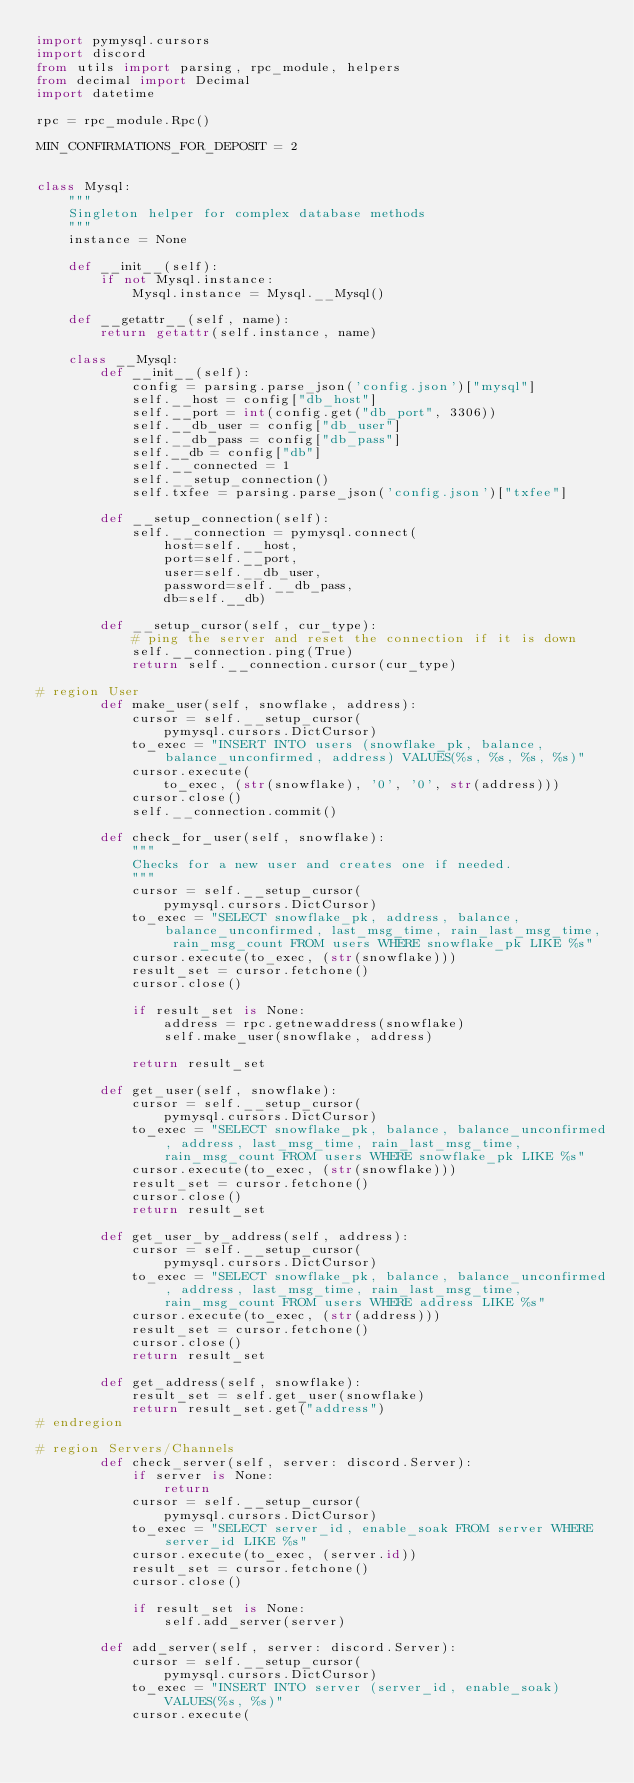Convert code to text. <code><loc_0><loc_0><loc_500><loc_500><_Python_>import pymysql.cursors
import discord
from utils import parsing, rpc_module, helpers
from decimal import Decimal
import datetime

rpc = rpc_module.Rpc()

MIN_CONFIRMATIONS_FOR_DEPOSIT = 2


class Mysql:
    """
    Singleton helper for complex database methods
    """
    instance = None

    def __init__(self):
        if not Mysql.instance:
            Mysql.instance = Mysql.__Mysql()

    def __getattr__(self, name):
        return getattr(self.instance, name)

    class __Mysql:
        def __init__(self):
            config = parsing.parse_json('config.json')["mysql"]
            self.__host = config["db_host"]
            self.__port = int(config.get("db_port", 3306))
            self.__db_user = config["db_user"]
            self.__db_pass = config["db_pass"]
            self.__db = config["db"]
            self.__connected = 1
            self.__setup_connection()
            self.txfee = parsing.parse_json('config.json')["txfee"]

        def __setup_connection(self):
            self.__connection = pymysql.connect(
                host=self.__host,
                port=self.__port,
                user=self.__db_user,
                password=self.__db_pass,
                db=self.__db)

        def __setup_cursor(self, cur_type):
            # ping the server and reset the connection if it is down
            self.__connection.ping(True)
            return self.__connection.cursor(cur_type)

# region User
        def make_user(self, snowflake, address):
            cursor = self.__setup_cursor(
                pymysql.cursors.DictCursor)
            to_exec = "INSERT INTO users (snowflake_pk, balance, balance_unconfirmed, address) VALUES(%s, %s, %s, %s)"
            cursor.execute(
                to_exec, (str(snowflake), '0', '0', str(address)))
            cursor.close()
            self.__connection.commit()

        def check_for_user(self, snowflake):
            """
            Checks for a new user and creates one if needed.
            """
            cursor = self.__setup_cursor(
                pymysql.cursors.DictCursor)
            to_exec = "SELECT snowflake_pk, address, balance, balance_unconfirmed, last_msg_time, rain_last_msg_time, rain_msg_count FROM users WHERE snowflake_pk LIKE %s"
            cursor.execute(to_exec, (str(snowflake)))
            result_set = cursor.fetchone()
            cursor.close()

            if result_set is None:
                address = rpc.getnewaddress(snowflake)
                self.make_user(snowflake, address)
            
            return result_set

        def get_user(self, snowflake):
            cursor = self.__setup_cursor(
                pymysql.cursors.DictCursor)
            to_exec = "SELECT snowflake_pk, balance, balance_unconfirmed, address, last_msg_time, rain_last_msg_time, rain_msg_count FROM users WHERE snowflake_pk LIKE %s"
            cursor.execute(to_exec, (str(snowflake)))
            result_set = cursor.fetchone()
            cursor.close()
            return result_set         

        def get_user_by_address(self, address):
            cursor = self.__setup_cursor(
                pymysql.cursors.DictCursor)           
            to_exec = "SELECT snowflake_pk, balance, balance_unconfirmed, address, last_msg_time, rain_last_msg_time, rain_msg_count FROM users WHERE address LIKE %s"
            cursor.execute(to_exec, (str(address)))
            result_set = cursor.fetchone()
            cursor.close()
            return result_set

        def get_address(self, snowflake):
            result_set = self.get_user(snowflake)
            return result_set.get("address")
# endregion

# region Servers/Channels
        def check_server(self, server: discord.Server):
            if server is None:
                return
            cursor = self.__setup_cursor(
                pymysql.cursors.DictCursor)        
            to_exec = "SELECT server_id, enable_soak FROM server WHERE server_id LIKE %s"
            cursor.execute(to_exec, (server.id))
            result_set = cursor.fetchone()
            cursor.close()

            if result_set is None:
                self.add_server(server)

        def add_server(self, server: discord.Server):
            cursor = self.__setup_cursor(
                pymysql.cursors.DictCursor)
            to_exec = "INSERT INTO server (server_id, enable_soak) VALUES(%s, %s)"
            cursor.execute(</code> 